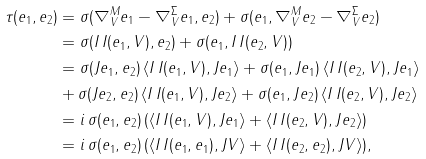Convert formula to latex. <formula><loc_0><loc_0><loc_500><loc_500>\tau ( e _ { 1 } , e _ { 2 } ) & = \sigma ( \nabla _ { V } ^ { M } e _ { 1 } - \nabla _ { V } ^ { \Sigma } e _ { 1 } , e _ { 2 } ) + \sigma ( e _ { 1 } , \nabla _ { V } ^ { M } e _ { 2 } - \nabla _ { V } ^ { \Sigma } e _ { 2 } ) \\ & = \sigma ( I \, I ( e _ { 1 } , V ) , e _ { 2 } ) + \sigma ( e _ { 1 } , I \, I ( e _ { 2 } , V ) ) \\ & = \sigma ( J e _ { 1 } , e _ { 2 } ) \, \langle I \, I ( e _ { 1 } , V ) , J e _ { 1 } \rangle + \sigma ( e _ { 1 } , J e _ { 1 } ) \, \langle I \, I ( e _ { 2 } , V ) , J e _ { 1 } \rangle \\ & + \sigma ( J e _ { 2 } , e _ { 2 } ) \, \langle I \, I ( e _ { 1 } , V ) , J e _ { 2 } \rangle + \sigma ( e _ { 1 } , J e _ { 2 } ) \, \langle I \, I ( e _ { 2 } , V ) , J e _ { 2 } \rangle \\ & = i \, \sigma ( e _ { 1 } , e _ { 2 } ) \, ( \langle I \, I ( e _ { 1 } , V ) , J e _ { 1 } \rangle + \langle I \, I ( e _ { 2 } , V ) , J e _ { 2 } \rangle ) \\ & = i \, \sigma ( e _ { 1 } , e _ { 2 } ) \, ( \langle I \, I ( e _ { 1 } , e _ { 1 } ) , J V \rangle + \langle I \, I ( e _ { 2 } , e _ { 2 } ) , J V \rangle ) ,</formula> 